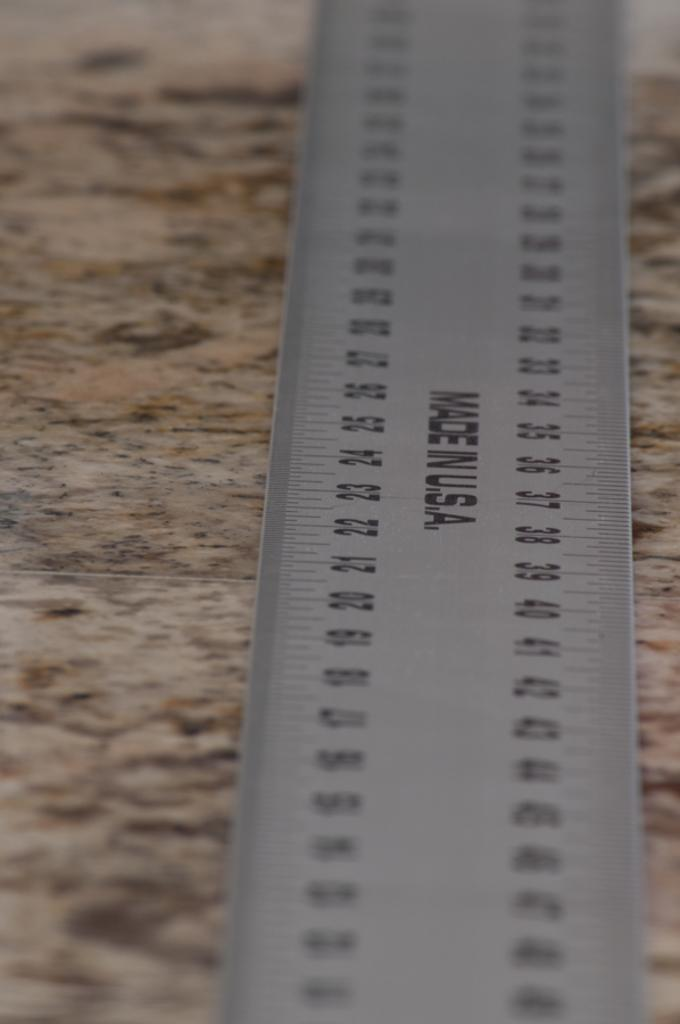<image>
Describe the image concisely. Ruler with numbers that was made in the USA 